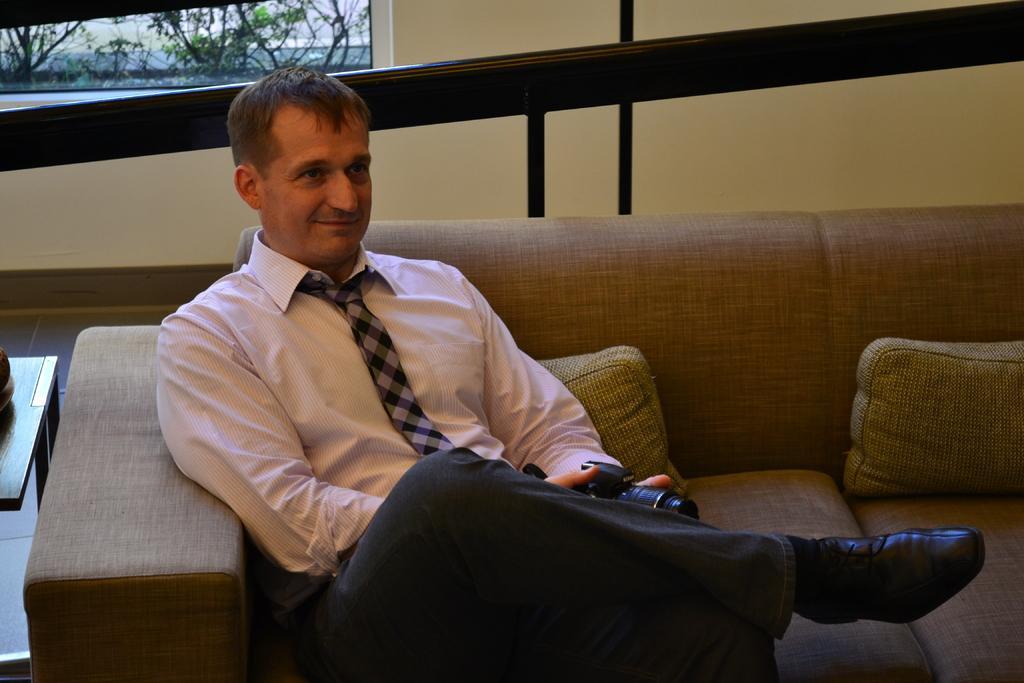Please provide a concise description of this image. In this image we can see a person holding the camera and sitting on the sofa. We can also see the cushions, a table, floor and also the wall. We can also see the plants through the window. 